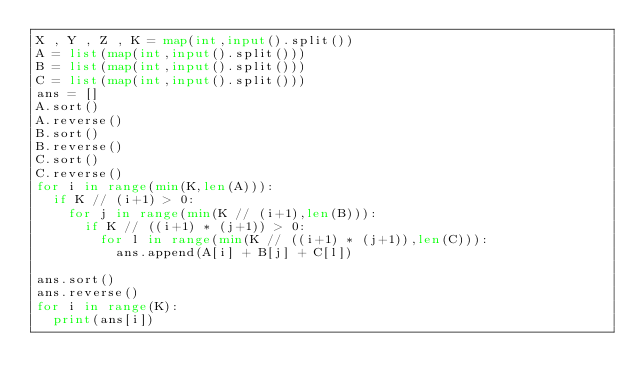<code> <loc_0><loc_0><loc_500><loc_500><_Python_>X , Y , Z , K = map(int,input().split())
A = list(map(int,input().split()))
B = list(map(int,input().split()))
C = list(map(int,input().split()))
ans = []
A.sort()
A.reverse()
B.sort()
B.reverse()
C.sort()
C.reverse()
for i in range(min(K,len(A))):
	if K // (i+1) > 0:
		for j in range(min(K // (i+1),len(B))):
			if K // ((i+1) * (j+1)) > 0:
				for l in range(min(K // ((i+1) * (j+1)),len(C))):
					ans.append(A[i] + B[j] + C[l])

ans.sort()
ans.reverse()
for i in range(K):
	print(ans[i])
	</code> 